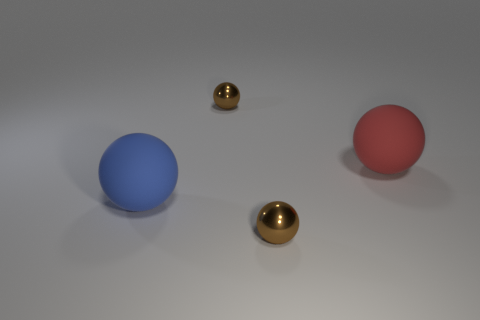Subtract all brown blocks. How many brown balls are left? 2 Subtract 2 spheres. How many spheres are left? 2 Subtract all big red rubber balls. How many balls are left? 3 Add 2 red matte balls. How many objects exist? 6 Subtract all red spheres. How many spheres are left? 3 Subtract all red spheres. Subtract all blue cubes. How many spheres are left? 3 Add 1 yellow things. How many yellow things exist? 1 Subtract 0 gray balls. How many objects are left? 4 Subtract all brown shiny objects. Subtract all blue rubber balls. How many objects are left? 1 Add 3 matte things. How many matte things are left? 5 